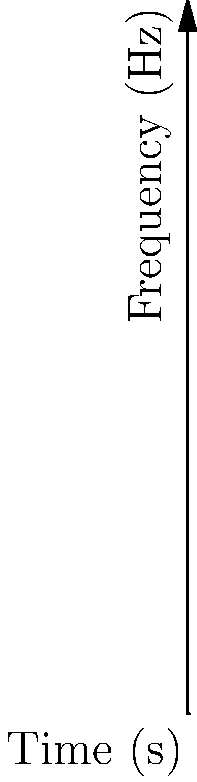In this spectrogram of a classic swing song, what musical element is likely represented by the cluster of high-intensity components around 3500 Hz at the 7-second mark? To answer this question, we need to analyze the spectrogram step-by-step:

1. Understand the axes:
   - The x-axis represents time in seconds.
   - The y-axis represents frequency in Hz.

2. Identify key components:
   - The fundamental frequency is typically found at lower frequencies (around 500 Hz in this case).
   - Harmonics appear as multiples of the fundamental frequency.
   - Different instruments and vocal elements occupy different frequency ranges.

3. Locate the area of interest:
   - We're looking at the region around 3500 Hz at the 7-second mark.

4. Analyze the characteristics:
   - The cluster appears to be high-intensity (darker color).
   - It's in a higher frequency range, above the typical range for vocals or rhythm section instruments.

5. Consider typical swing instrumentation:
   - Swing music often features a prominent brass section (trumpets, trombones, saxophones).
   - Brass instruments, especially when playing loudly or in a high register, produce strong high-frequency components.

6. Match the characteristics:
   - The high-intensity, high-frequency cluster is consistent with the bright, piercing sound of a brass section in full swing.

Therefore, the cluster likely represents the brass section of the swing band, playing a prominent part or solo at this point in the song.
Answer: Brass section 